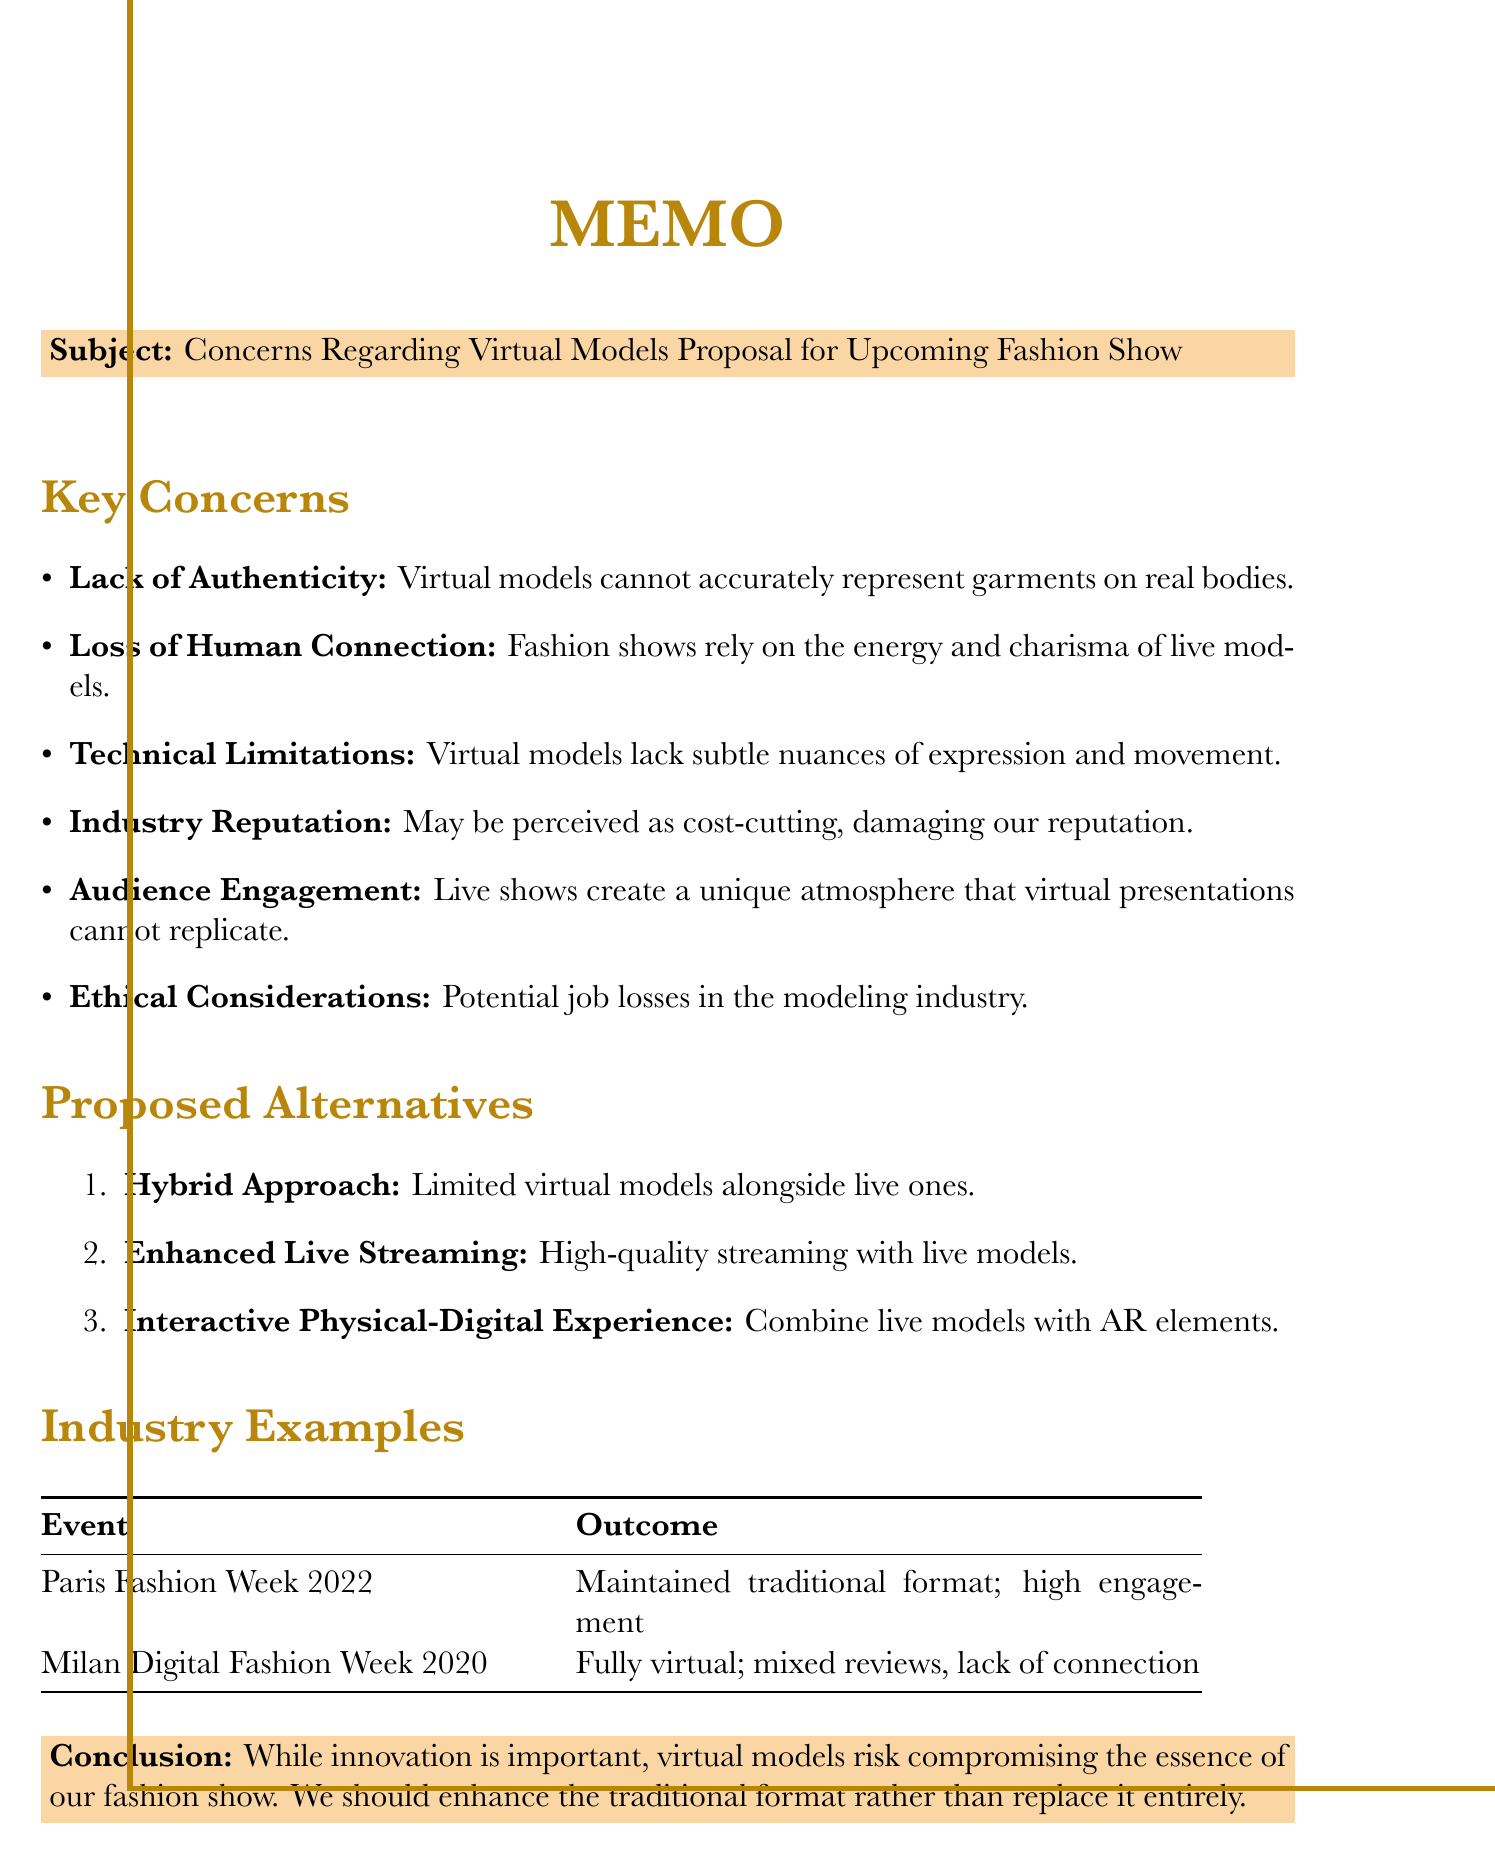What is the subject of the memo? The subject of the memo is explicitly stated at the beginning, highlighting the main concern regarding the proposal.
Answer: Concerns Regarding Virtual Models Proposal for Upcoming Fashion Show How many key concerns are listed in the memo? The number of key concerns can be found by counting the items in the list noted under "Key Concerns".
Answer: Six What is one of the proposed alternatives mentioned in the memo? The proposed alternatives are outlined in a specific section; any single alternative will suffice.
Answer: Hybrid Approach Which event maintained the traditional model format in 2022? The successful event in 2022 is clearly detailed in the "Industry Examples" section.
Answer: Paris Fashion Week 2022 What is one ethical consideration highlighted in the memo? The ethical considerations are outlined clearly in the document, indicating potential impacts.
Answer: Job losses in the modeling industry What is the conclusion of the memo? The conclusion summarizes the overall sentiment regarding virtual models and traditional formats.
Answer: Virtual models risk compromising the essence of our fashion show Which industry's reputation is at risk according to the memo? The document specifically mentions the impact on reputation regarding high-end designers due to the proposal.
Answer: Fashion industry 